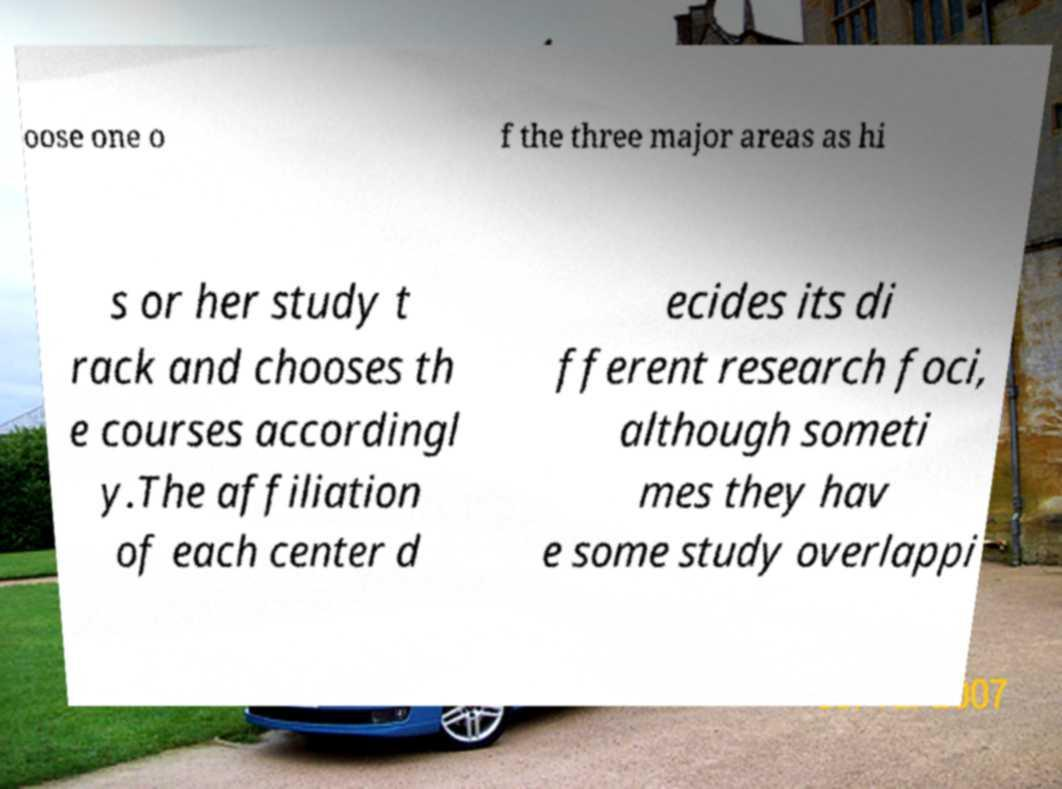Could you extract and type out the text from this image? oose one o f the three major areas as hi s or her study t rack and chooses th e courses accordingl y.The affiliation of each center d ecides its di fferent research foci, although someti mes they hav e some study overlappi 